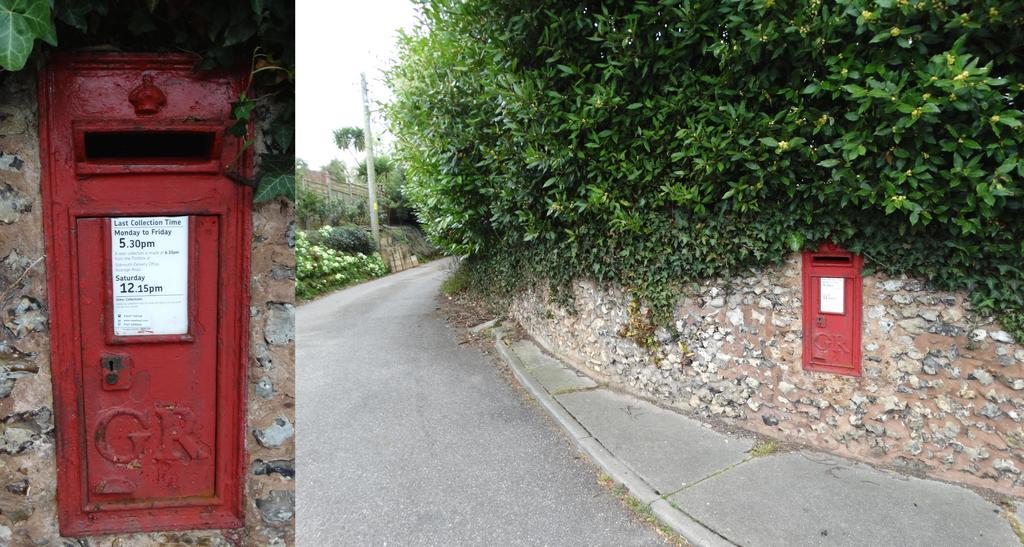What is the main feature in the middle of the image? There is a road in the middle of the image. What can be seen on either side of the road? Plants are present on either side of the road. Where is the postbox located in the image? The postbox is on the wall on the left side of the image. How many men are holding wine glasses in the image? There are no men or wine glasses present in the image. 